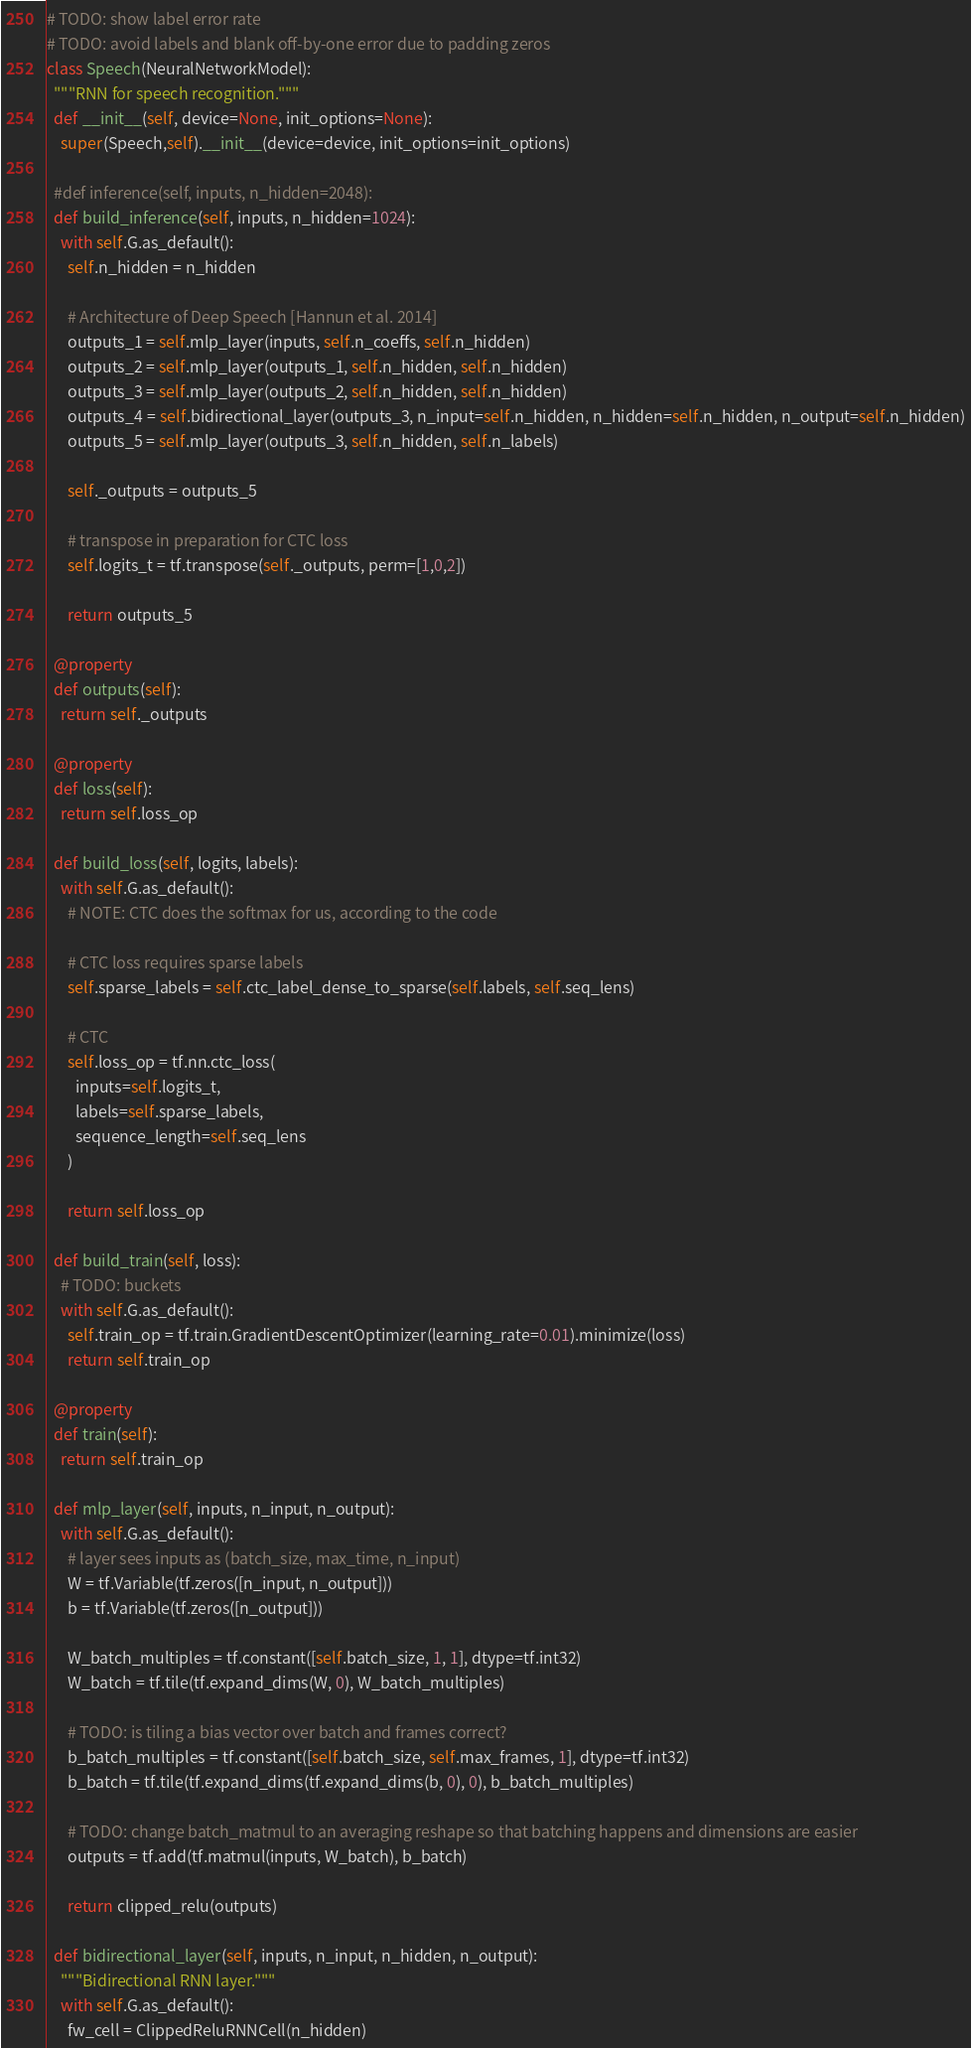<code> <loc_0><loc_0><loc_500><loc_500><_Python_>

# TODO: show label error rate
# TODO: avoid labels and blank off-by-one error due to padding zeros
class Speech(NeuralNetworkModel):
  """RNN for speech recognition."""
  def __init__(self, device=None, init_options=None):
    super(Speech,self).__init__(device=device, init_options=init_options)

  #def inference(self, inputs, n_hidden=2048):
  def build_inference(self, inputs, n_hidden=1024):
    with self.G.as_default():
      self.n_hidden = n_hidden

      # Architecture of Deep Speech [Hannun et al. 2014]
      outputs_1 = self.mlp_layer(inputs, self.n_coeffs, self.n_hidden)
      outputs_2 = self.mlp_layer(outputs_1, self.n_hidden, self.n_hidden)
      outputs_3 = self.mlp_layer(outputs_2, self.n_hidden, self.n_hidden)
      outputs_4 = self.bidirectional_layer(outputs_3, n_input=self.n_hidden, n_hidden=self.n_hidden, n_output=self.n_hidden)
      outputs_5 = self.mlp_layer(outputs_3, self.n_hidden, self.n_labels)

      self._outputs = outputs_5

      # transpose in preparation for CTC loss
      self.logits_t = tf.transpose(self._outputs, perm=[1,0,2])

      return outputs_5

  @property
  def outputs(self):
    return self._outputs

  @property
  def loss(self):
    return self.loss_op

  def build_loss(self, logits, labels):
    with self.G.as_default():
      # NOTE: CTC does the softmax for us, according to the code

      # CTC loss requires sparse labels
      self.sparse_labels = self.ctc_label_dense_to_sparse(self.labels, self.seq_lens)

      # CTC
      self.loss_op = tf.nn.ctc_loss(
        inputs=self.logits_t,
        labels=self.sparse_labels,
        sequence_length=self.seq_lens
      )

      return self.loss_op

  def build_train(self, loss):
    # TODO: buckets
    with self.G.as_default():
      self.train_op = tf.train.GradientDescentOptimizer(learning_rate=0.01).minimize(loss)
      return self.train_op

  @property
  def train(self):
    return self.train_op

  def mlp_layer(self, inputs, n_input, n_output):
    with self.G.as_default():
      # layer sees inputs as (batch_size, max_time, n_input)
      W = tf.Variable(tf.zeros([n_input, n_output]))
      b = tf.Variable(tf.zeros([n_output]))

      W_batch_multiples = tf.constant([self.batch_size, 1, 1], dtype=tf.int32)
      W_batch = tf.tile(tf.expand_dims(W, 0), W_batch_multiples)

      # TODO: is tiling a bias vector over batch and frames correct?
      b_batch_multiples = tf.constant([self.batch_size, self.max_frames, 1], dtype=tf.int32)
      b_batch = tf.tile(tf.expand_dims(tf.expand_dims(b, 0), 0), b_batch_multiples)

      # TODO: change batch_matmul to an averaging reshape so that batching happens and dimensions are easier
      outputs = tf.add(tf.matmul(inputs, W_batch), b_batch)

      return clipped_relu(outputs)

  def bidirectional_layer(self, inputs, n_input, n_hidden, n_output):
    """Bidirectional RNN layer."""
    with self.G.as_default():
      fw_cell = ClippedReluRNNCell(n_hidden)</code> 